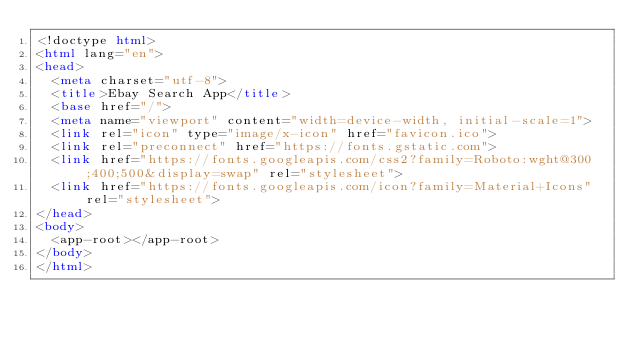<code> <loc_0><loc_0><loc_500><loc_500><_HTML_><!doctype html>
<html lang="en">
<head>
  <meta charset="utf-8">
  <title>Ebay Search App</title>
  <base href="/">
  <meta name="viewport" content="width=device-width, initial-scale=1">
  <link rel="icon" type="image/x-icon" href="favicon.ico">
  <link rel="preconnect" href="https://fonts.gstatic.com">
  <link href="https://fonts.googleapis.com/css2?family=Roboto:wght@300;400;500&display=swap" rel="stylesheet">
  <link href="https://fonts.googleapis.com/icon?family=Material+Icons" rel="stylesheet">
</head>
<body>
  <app-root></app-root>
</body>
</html>
</code> 